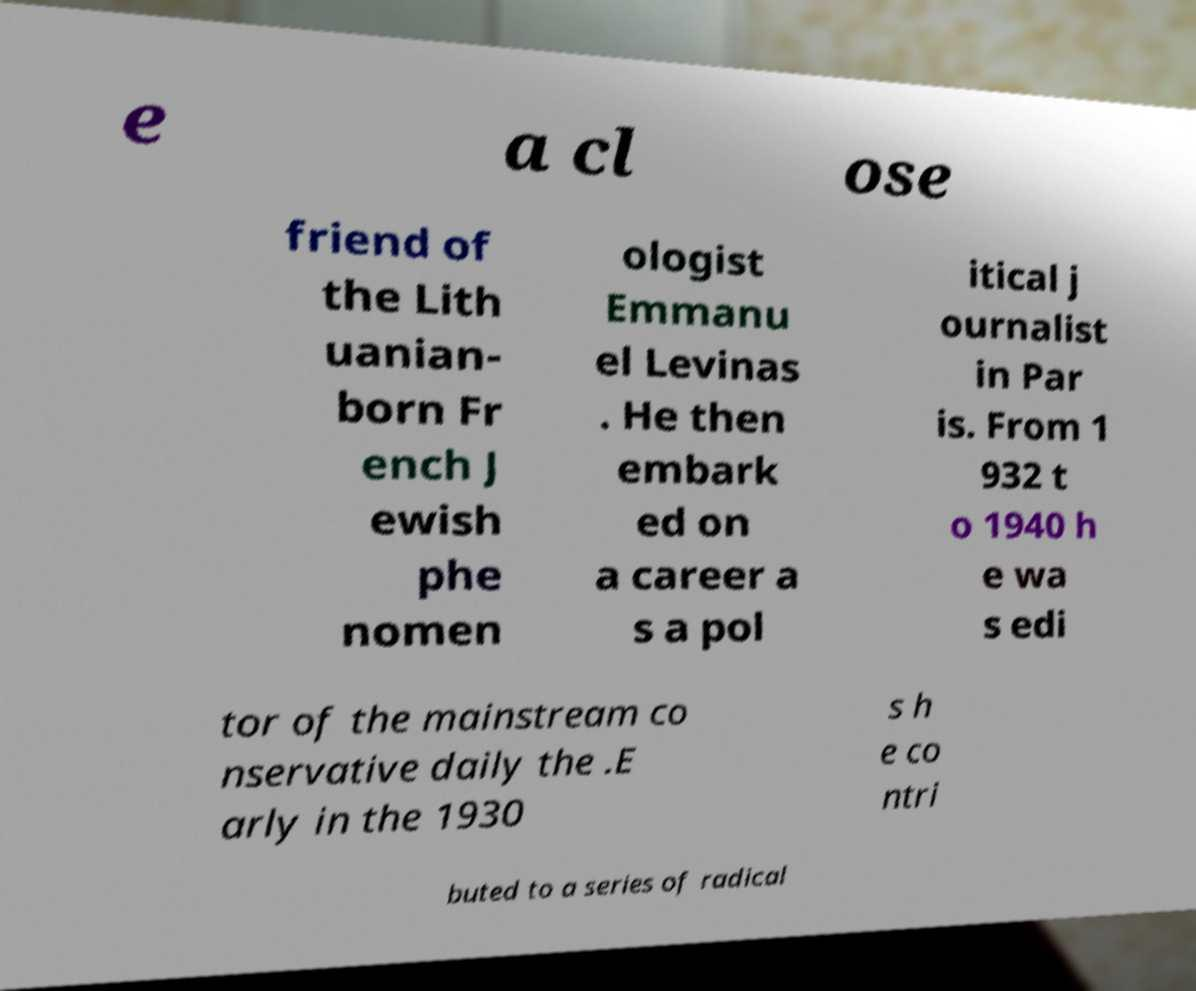For documentation purposes, I need the text within this image transcribed. Could you provide that? e a cl ose friend of the Lith uanian- born Fr ench J ewish phe nomen ologist Emmanu el Levinas . He then embark ed on a career a s a pol itical j ournalist in Par is. From 1 932 t o 1940 h e wa s edi tor of the mainstream co nservative daily the .E arly in the 1930 s h e co ntri buted to a series of radical 